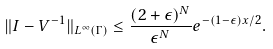Convert formula to latex. <formula><loc_0><loc_0><loc_500><loc_500>\| I - V ^ { - 1 } \| _ { L ^ { \infty } ( \Gamma ) } \leq \frac { ( 2 + \epsilon ) ^ { N } } { \epsilon ^ { N } } e ^ { - ( 1 - \epsilon ) x / 2 } .</formula> 